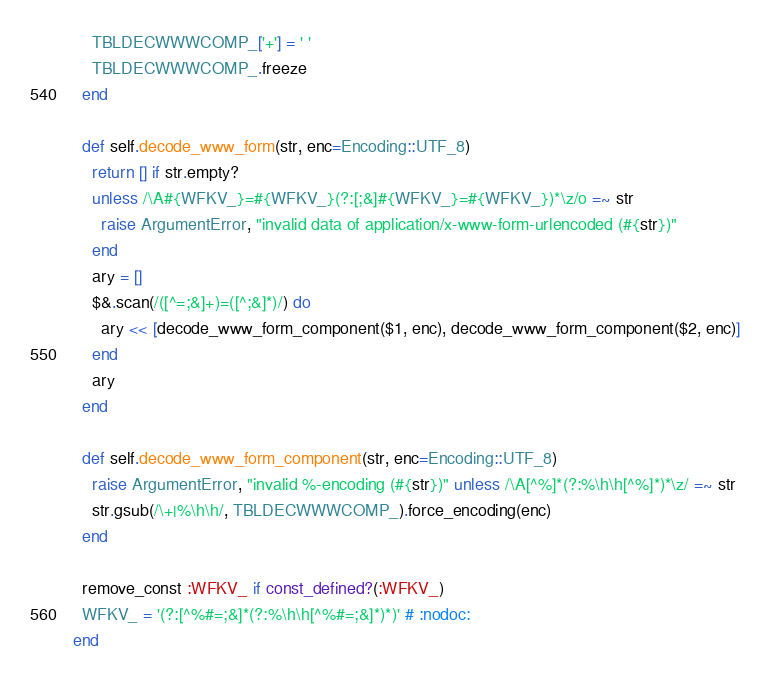<code> <loc_0><loc_0><loc_500><loc_500><_Ruby_>    TBLDECWWWCOMP_['+'] = ' '
    TBLDECWWWCOMP_.freeze
  end

  def self.decode_www_form(str, enc=Encoding::UTF_8)
    return [] if str.empty?
    unless /\A#{WFKV_}=#{WFKV_}(?:[;&]#{WFKV_}=#{WFKV_})*\z/o =~ str
      raise ArgumentError, "invalid data of application/x-www-form-urlencoded (#{str})"
    end
    ary = []
    $&.scan(/([^=;&]+)=([^;&]*)/) do
      ary << [decode_www_form_component($1, enc), decode_www_form_component($2, enc)]
    end
    ary
  end

  def self.decode_www_form_component(str, enc=Encoding::UTF_8)
    raise ArgumentError, "invalid %-encoding (#{str})" unless /\A[^%]*(?:%\h\h[^%]*)*\z/ =~ str
    str.gsub(/\+|%\h\h/, TBLDECWWWCOMP_).force_encoding(enc)
  end

  remove_const :WFKV_ if const_defined?(:WFKV_)
  WFKV_ = '(?:[^%#=;&]*(?:%\h\h[^%#=;&]*)*)' # :nodoc:
end
</code> 